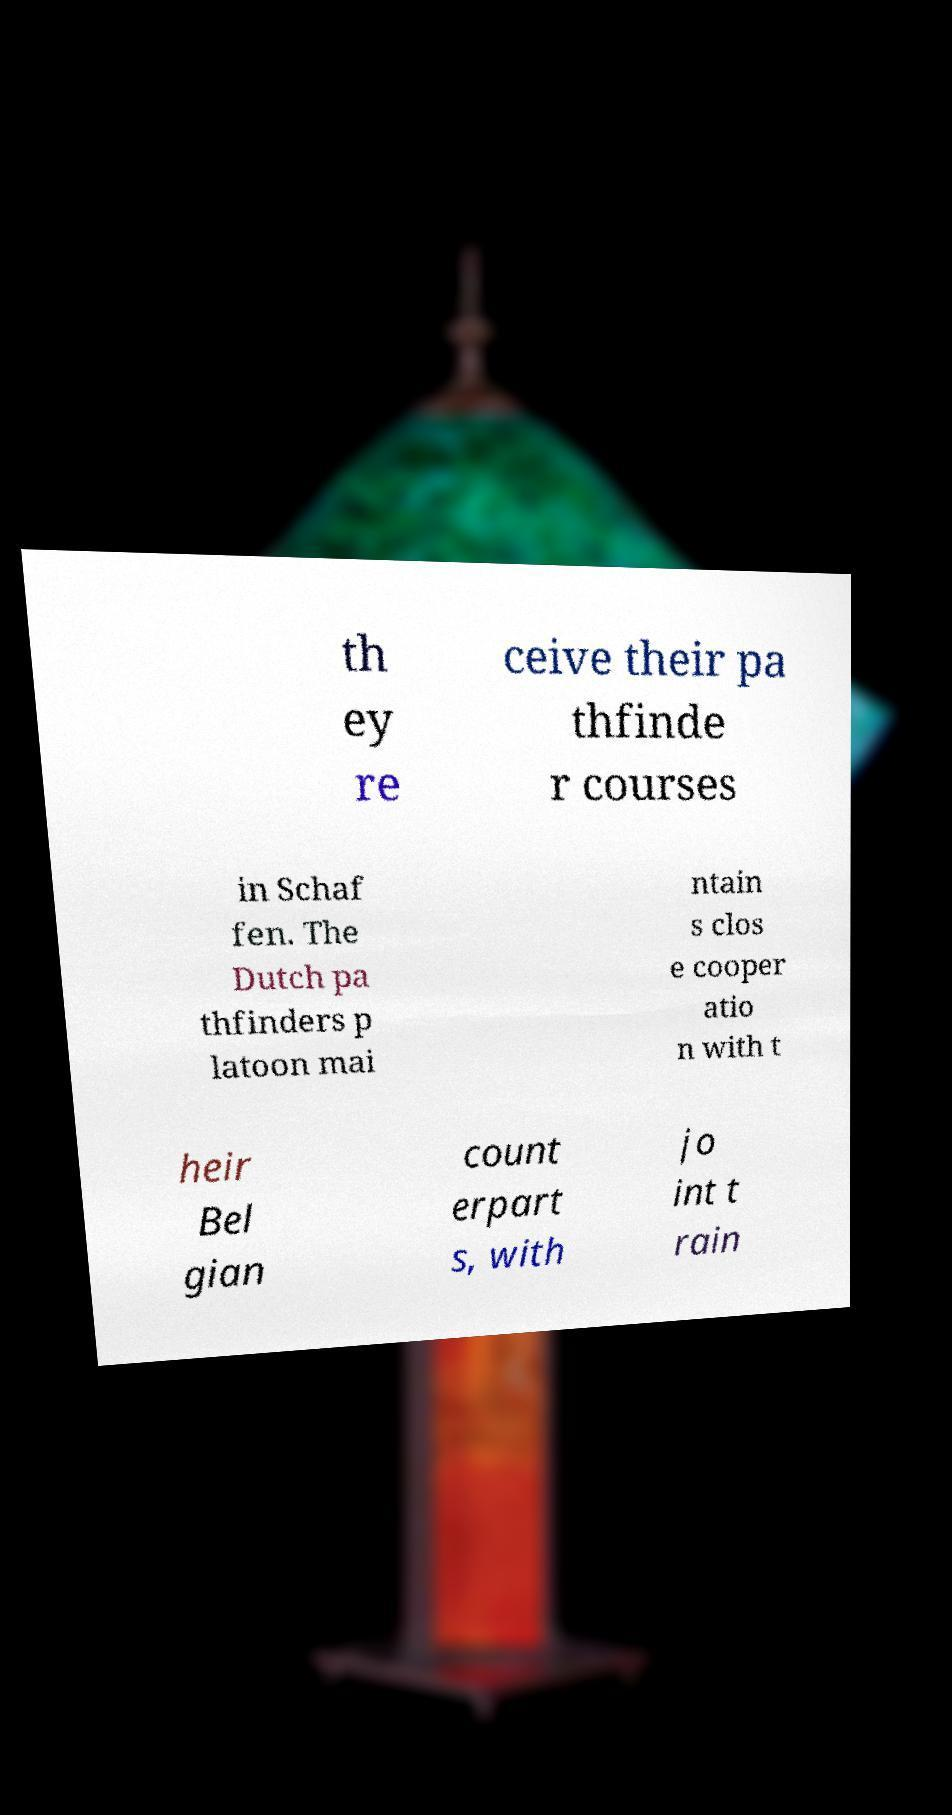Please read and relay the text visible in this image. What does it say? th ey re ceive their pa thfinde r courses in Schaf fen. The Dutch pa thfinders p latoon mai ntain s clos e cooper atio n with t heir Bel gian count erpart s, with jo int t rain 